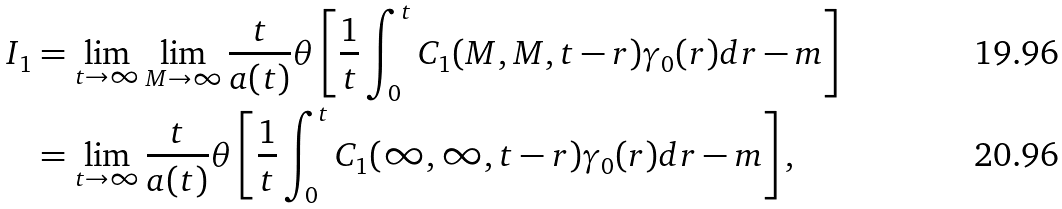<formula> <loc_0><loc_0><loc_500><loc_500>I _ { 1 } & = \lim _ { t \rightarrow \infty } \lim _ { M \rightarrow \infty } \frac { t } { a ( t ) } \theta \left [ \frac { 1 } { t } \int _ { 0 } ^ { t } C _ { 1 } ( M , M , t - r ) \gamma _ { 0 } ( r ) d r - m \right ] \\ & = \lim _ { t \rightarrow \infty } \frac { t } { a ( t ) } \theta \left [ \frac { 1 } { t } \int _ { 0 } ^ { t } C _ { 1 } ( \infty , \infty , t - r ) \gamma _ { 0 } ( r ) d r - m \right ] ,</formula> 